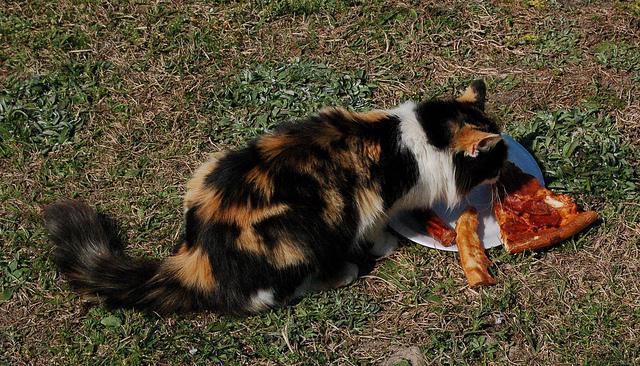How many animals?
Give a very brief answer. 1. 